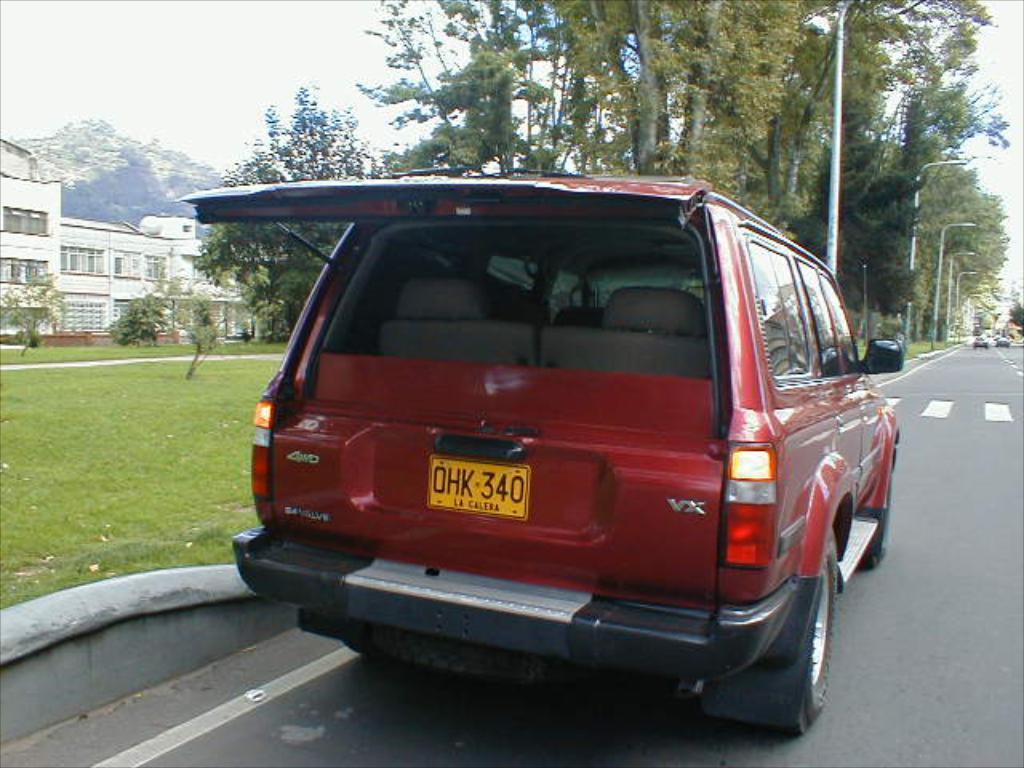Please provide a concise description of this image. In this picture I can see there is a vehicle parked here on the road and there is a building, a mountain and trees in the backdrop and the sky is clear. 